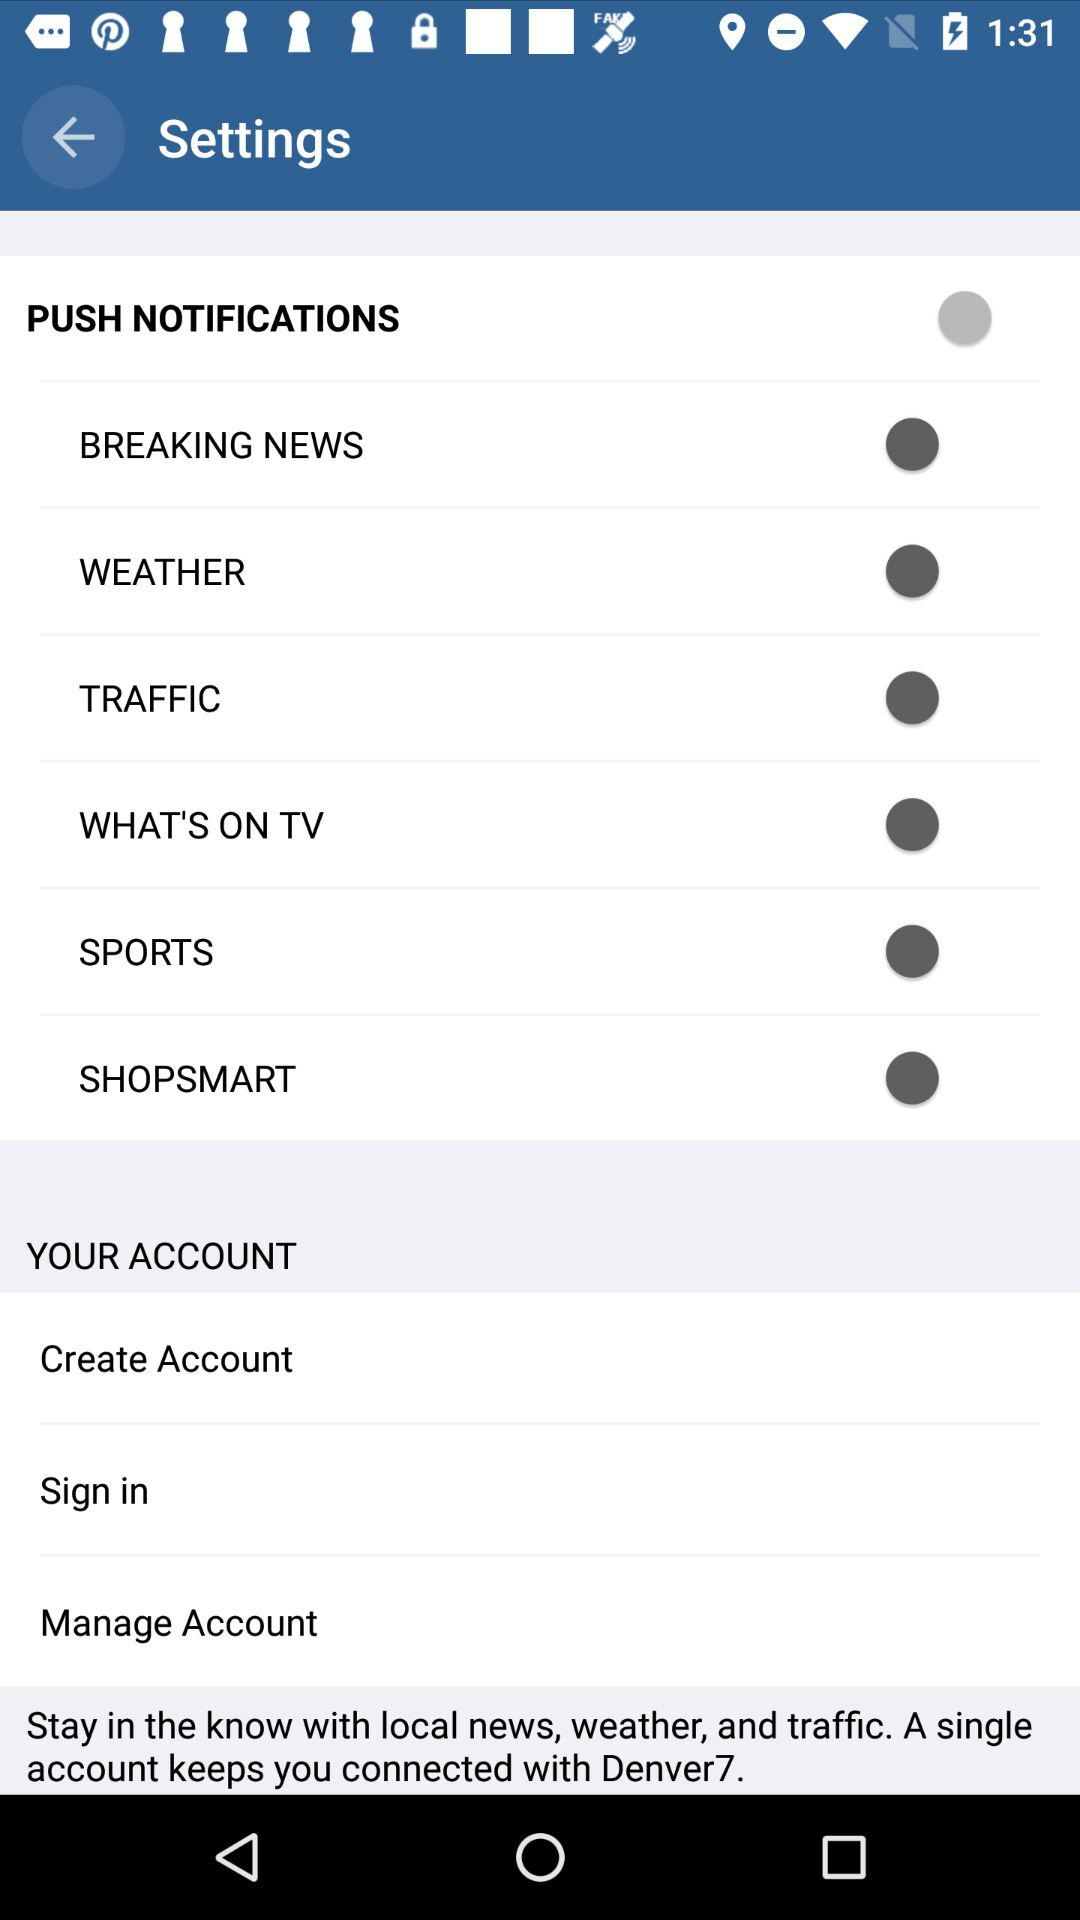What is the status of "Breaking News"? The status of "Breaking News" is "on". 